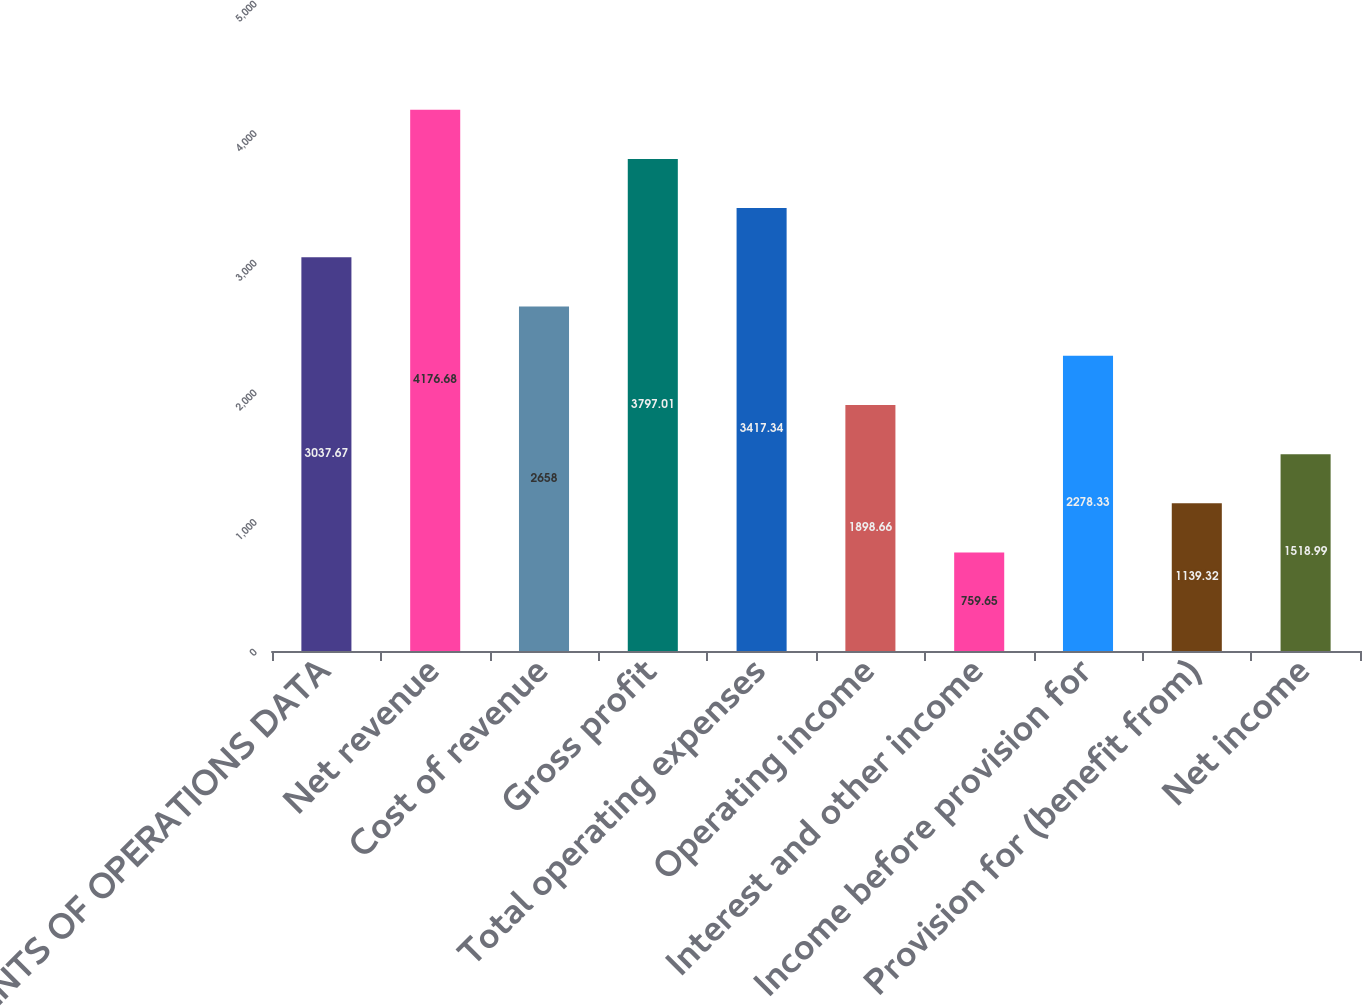<chart> <loc_0><loc_0><loc_500><loc_500><bar_chart><fcel>STATEMENTS OF OPERATIONS DATA<fcel>Net revenue<fcel>Cost of revenue<fcel>Gross profit<fcel>Total operating expenses<fcel>Operating income<fcel>Interest and other income<fcel>Income before provision for<fcel>Provision for (benefit from)<fcel>Net income<nl><fcel>3037.67<fcel>4176.68<fcel>2658<fcel>3797.01<fcel>3417.34<fcel>1898.66<fcel>759.65<fcel>2278.33<fcel>1139.32<fcel>1518.99<nl></chart> 